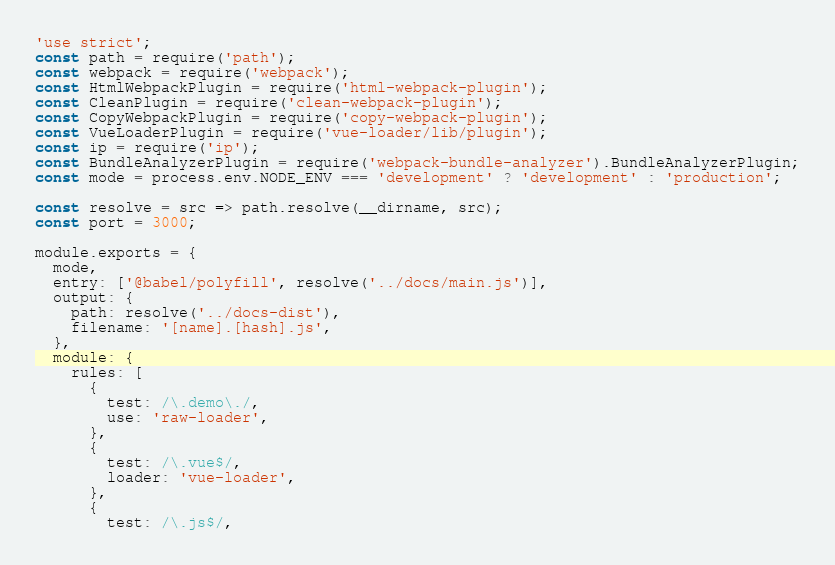<code> <loc_0><loc_0><loc_500><loc_500><_JavaScript_>'use strict';
const path = require('path');
const webpack = require('webpack');
const HtmlWebpackPlugin = require('html-webpack-plugin');
const CleanPlugin = require('clean-webpack-plugin');
const CopyWebpackPlugin = require('copy-webpack-plugin');
const VueLoaderPlugin = require('vue-loader/lib/plugin');
const ip = require('ip');
const BundleAnalyzerPlugin = require('webpack-bundle-analyzer').BundleAnalyzerPlugin;
const mode = process.env.NODE_ENV === 'development' ? 'development' : 'production';

const resolve = src => path.resolve(__dirname, src);
const port = 3000;

module.exports = {
  mode,
  entry: ['@babel/polyfill', resolve('../docs/main.js')],
  output: {
    path: resolve('../docs-dist'),
    filename: '[name].[hash].js',
  },
  module: {
    rules: [
      {
        test: /\.demo\./,
        use: 'raw-loader',
      },
      {
        test: /\.vue$/,
        loader: 'vue-loader',
      },
      {
        test: /\.js$/,</code> 